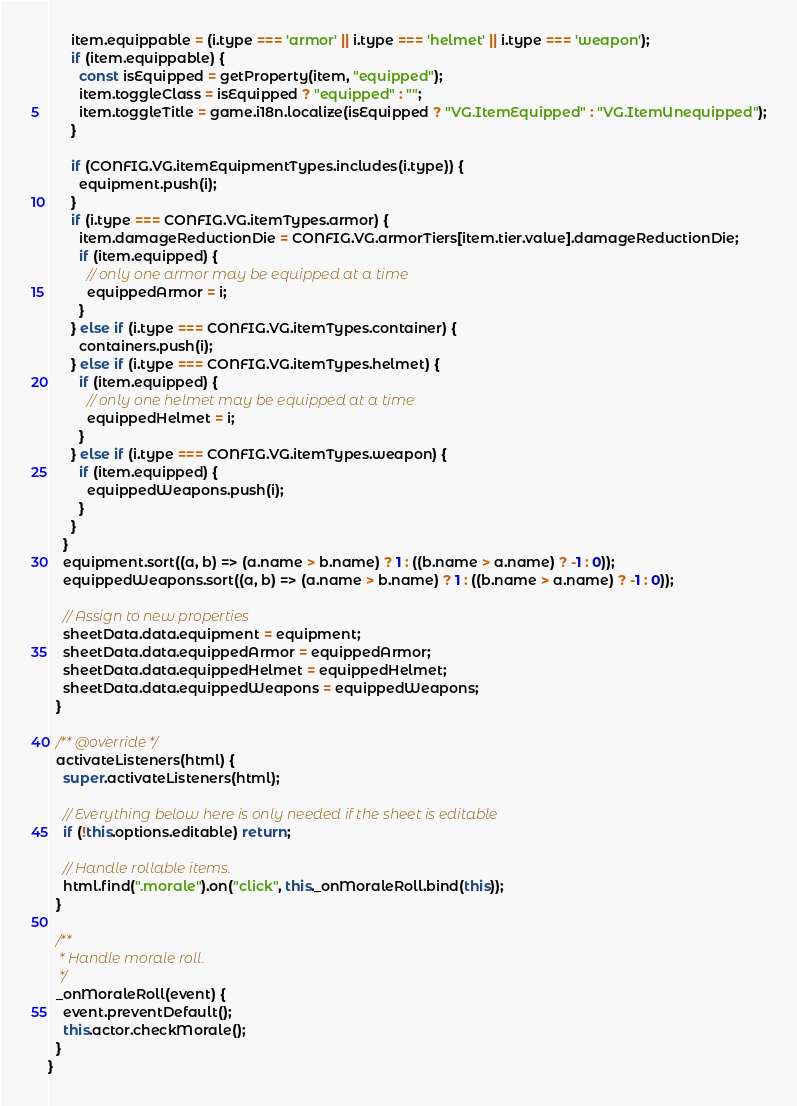<code> <loc_0><loc_0><loc_500><loc_500><_JavaScript_>      item.equippable = (i.type === 'armor' || i.type === 'helmet' || i.type === 'weapon');
      if (item.equippable) {
        const isEquipped = getProperty(item, "equipped");
        item.toggleClass = isEquipped ? "equipped" : "";
        item.toggleTitle = game.i18n.localize(isEquipped ? "VG.ItemEquipped" : "VG.ItemUnequipped");
      }

      if (CONFIG.VG.itemEquipmentTypes.includes(i.type)) {
        equipment.push(i);
      }      
      if (i.type === CONFIG.VG.itemTypes.armor) {
        item.damageReductionDie = CONFIG.VG.armorTiers[item.tier.value].damageReductionDie;
        if (item.equipped) {
          // only one armor may be equipped at a time
          equippedArmor = i;
        }
      } else if (i.type === CONFIG.VG.itemTypes.container) {
        containers.push(i);
      } else if (i.type === CONFIG.VG.itemTypes.helmet) {
        if (item.equipped) {
          // only one helmet may be equipped at a time
          equippedHelmet = i;
        }
      } else if (i.type === CONFIG.VG.itemTypes.weapon) {
        if (item.equipped) {
          equippedWeapons.push(i);
        }
      }
    }
    equipment.sort((a, b) => (a.name > b.name) ? 1 : ((b.name > a.name) ? -1 : 0));
    equippedWeapons.sort((a, b) => (a.name > b.name) ? 1 : ((b.name > a.name) ? -1 : 0));

    // Assign to new properties
    sheetData.data.equipment = equipment;
    sheetData.data.equippedArmor = equippedArmor;
    sheetData.data.equippedHelmet = equippedHelmet;
    sheetData.data.equippedWeapons = equippedWeapons;
  }

  /** @override */
  activateListeners(html) {
    super.activateListeners(html);

    // Everything below here is only needed if the sheet is editable
    if (!this.options.editable) return;

    // Handle rollable items.
    html.find(".morale").on("click", this._onMoraleRoll.bind(this));
  }

  /**
   * Handle morale roll.
   */
  _onMoraleRoll(event) {
    event.preventDefault();   
    this.actor.checkMorale();
  }  
}
</code> 